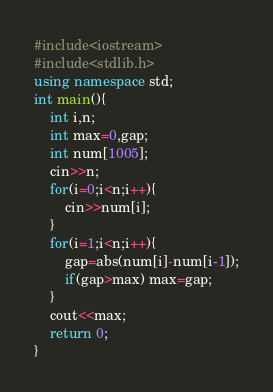<code> <loc_0><loc_0><loc_500><loc_500><_C++_>#include<iostream>
#include<stdlib.h>
using namespace std;
int main(){
	int i,n;
	int max=0,gap;
	int num[1005];
	cin>>n;
	for(i=0;i<n;i++){
		cin>>num[i];
	}
	for(i=1;i<n;i++){
		gap=abs(num[i]-num[i-1]);
		if(gap>max) max=gap;
	}
	cout<<max;
	return 0;
}
</code> 